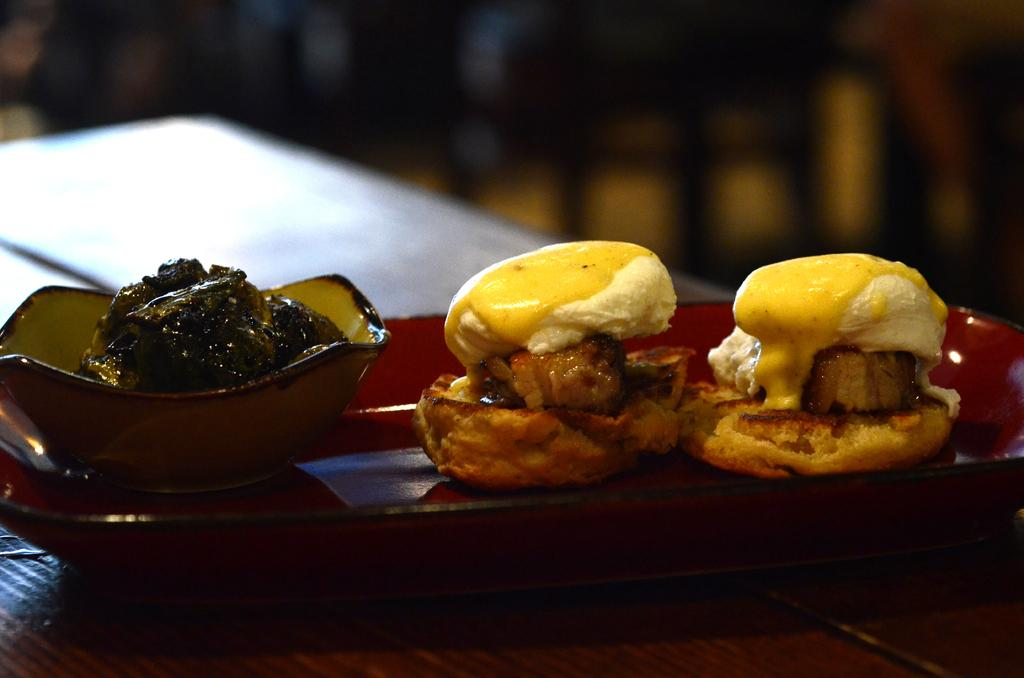What type of food item is visible in the image? There is a food item in the image, but its specific type cannot be determined from the provided facts. What colors can be seen in the food item? The food item has white, brown, and yellow colors. How is the food item presented in the image? The food item is placed on a red plate. Can you see any veins in the food item in the image? There is no mention of veins in the food item in the image, and therefore it cannot be determined if any are present. What is the tendency of the pot in the image? There is no pot present in the image, so its tendency cannot be determined. 